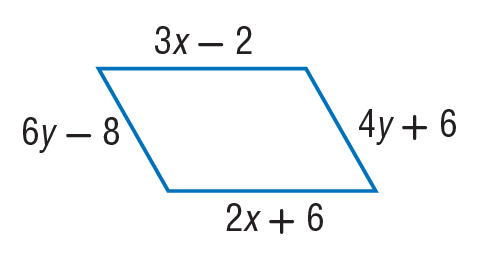Answer the mathemtical geometry problem and directly provide the correct option letter.
Question: Find x so that the quadrilateral is a parallelogram.
Choices: A: 8 B: 22 C: 24 D: 40 A 